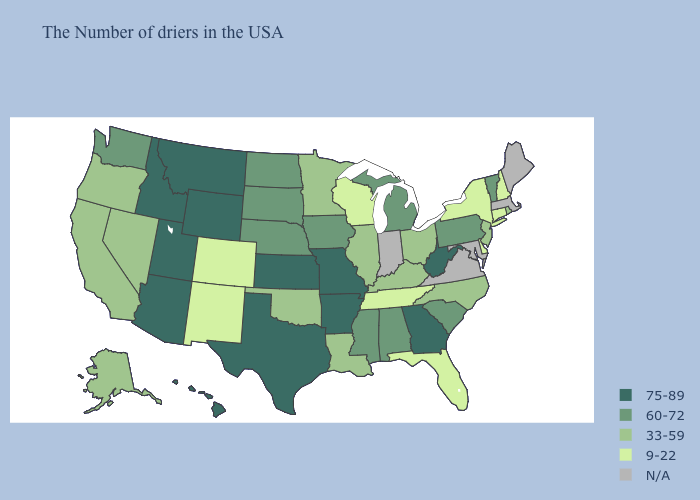Does Kentucky have the lowest value in the USA?
Be succinct. No. Name the states that have a value in the range 75-89?
Answer briefly. West Virginia, Georgia, Missouri, Arkansas, Kansas, Texas, Wyoming, Utah, Montana, Arizona, Idaho, Hawaii. What is the lowest value in states that border Utah?
Keep it brief. 9-22. Among the states that border Missouri , which have the highest value?
Give a very brief answer. Arkansas, Kansas. What is the highest value in the South ?
Short answer required. 75-89. Name the states that have a value in the range 60-72?
Concise answer only. Vermont, Pennsylvania, South Carolina, Michigan, Alabama, Mississippi, Iowa, Nebraska, South Dakota, North Dakota, Washington. What is the value of Illinois?
Give a very brief answer. 33-59. Name the states that have a value in the range 33-59?
Write a very short answer. Rhode Island, New Jersey, North Carolina, Ohio, Kentucky, Illinois, Louisiana, Minnesota, Oklahoma, Nevada, California, Oregon, Alaska. What is the lowest value in states that border South Carolina?
Keep it brief. 33-59. Among the states that border Massachusetts , which have the highest value?
Answer briefly. Vermont. Among the states that border Kentucky , does Illinois have the highest value?
Be succinct. No. What is the lowest value in the USA?
Quick response, please. 9-22. What is the value of Nebraska?
Answer briefly. 60-72. What is the lowest value in the USA?
Answer briefly. 9-22. 